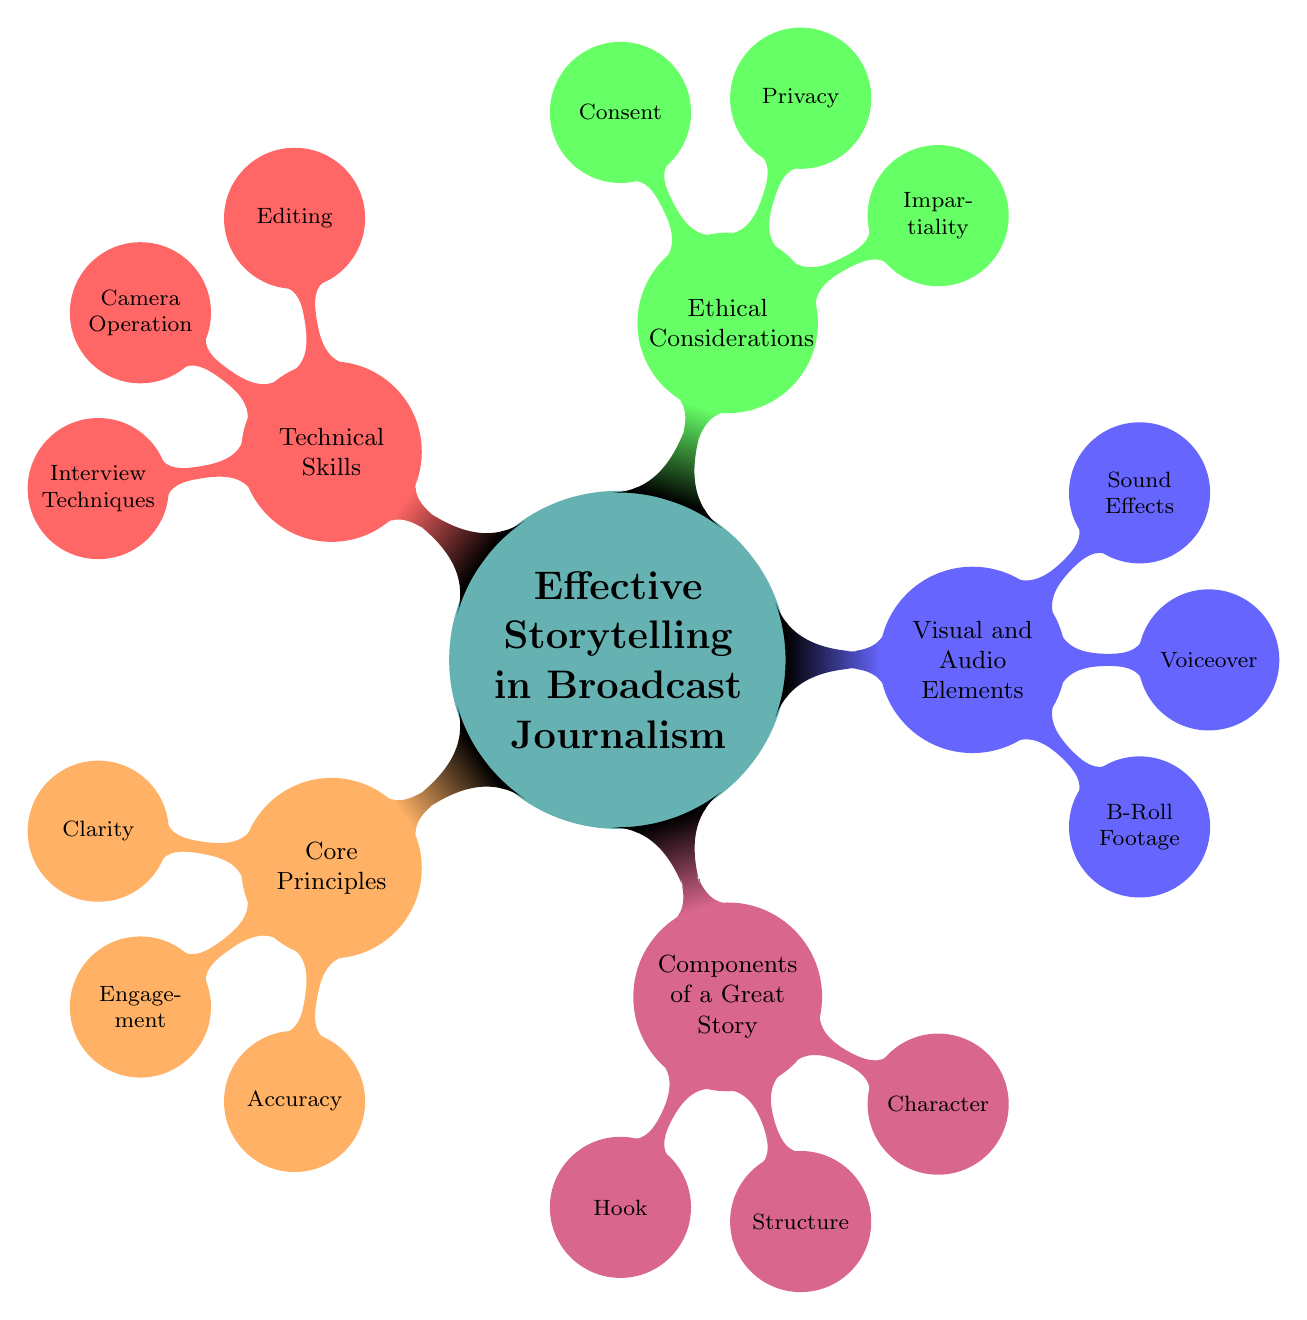What is one of the core principles listed in the diagram? The diagram shows several nodes under the "Core Principles" category, one of which is "Clarity."
Answer: Clarity How many visual and audio elements are mentioned in the diagram? The "Visual and Audio Elements" section contains three nodes: "B-Roll Footage," "Voiceover," and "Sound Effects," which totals three elements.
Answer: Three What is the relationship between "Structure" and “Components of a Great Story”? "Structure" is a child node of the "Components of a Great Story" node, indicating that it is part of the elements that make up a great story.
Answer: Structure is part of Components of a Great Story Which technique is associated with editing in the technical skills section? Under "Technical Skills," the node corresponding to editing is "Editing," indicating that this is the skill relevant to that section.
Answer: Editing What are the three components of a great story listed in the diagram? The components listed are "Hook," "Structure," and "Character," as shown under the "Components of a Great Story" section.
Answer: Hook, Structure, Character Which ethical consideration indicates the need for fairness in reporting? The node "Impartiality" from the "Ethical Considerations" section signals the importance of balanced and fair reporting.
Answer: Impartiality How does the visual and audio elements section contribute to effective storytelling? The visual and audio elements such as "B-Roll Footage," "Voiceover," and "Sound Effects" enhance the narrative and engage the audience, contributing significantly to effective storytelling.
Answer: Enhance narrative and engage audience What is the total number of nodes in the diagram? The diagram includes a main node along with five branches each containing three child nodes. This totals to one main node plus fifteen child nodes, equaling sixteen nodes overall.
Answer: Sixteen Which principle ensures that information should be correct and credible? "Accuracy" is the principle that emphasizes the need for factual and credible information under the "Core Principles."
Answer: Accuracy 